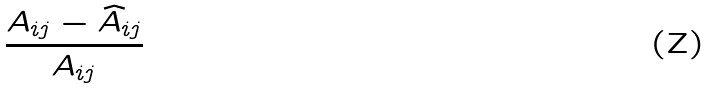Convert formula to latex. <formula><loc_0><loc_0><loc_500><loc_500>\frac { A _ { i j } - \widehat { A } _ { i j } } { A _ { i j } }</formula> 